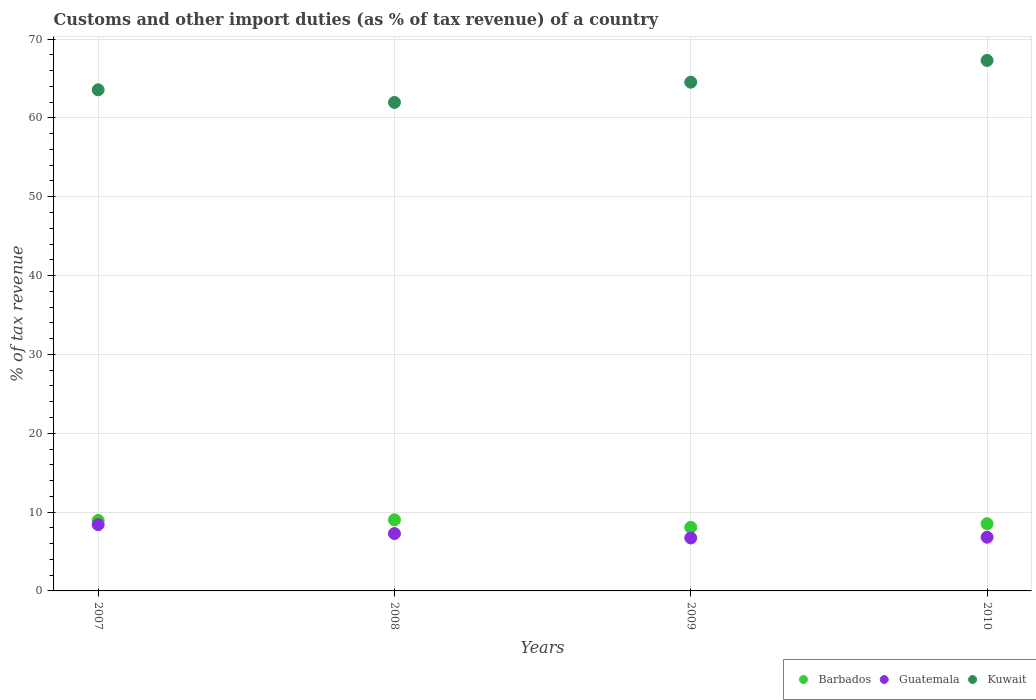Is the number of dotlines equal to the number of legend labels?
Offer a terse response. Yes. What is the percentage of tax revenue from customs in Kuwait in 2008?
Give a very brief answer. 61.96. Across all years, what is the maximum percentage of tax revenue from customs in Barbados?
Your response must be concise. 9.02. Across all years, what is the minimum percentage of tax revenue from customs in Kuwait?
Offer a terse response. 61.96. In which year was the percentage of tax revenue from customs in Guatemala maximum?
Give a very brief answer. 2007. In which year was the percentage of tax revenue from customs in Barbados minimum?
Your answer should be very brief. 2009. What is the total percentage of tax revenue from customs in Kuwait in the graph?
Keep it short and to the point. 257.33. What is the difference between the percentage of tax revenue from customs in Kuwait in 2007 and that in 2010?
Keep it short and to the point. -3.72. What is the difference between the percentage of tax revenue from customs in Kuwait in 2009 and the percentage of tax revenue from customs in Guatemala in 2008?
Your answer should be compact. 57.25. What is the average percentage of tax revenue from customs in Kuwait per year?
Provide a succinct answer. 64.33. In the year 2010, what is the difference between the percentage of tax revenue from customs in Barbados and percentage of tax revenue from customs in Kuwait?
Provide a succinct answer. -58.76. In how many years, is the percentage of tax revenue from customs in Barbados greater than 64 %?
Your response must be concise. 0. What is the ratio of the percentage of tax revenue from customs in Kuwait in 2007 to that in 2008?
Your answer should be very brief. 1.03. Is the difference between the percentage of tax revenue from customs in Barbados in 2007 and 2010 greater than the difference between the percentage of tax revenue from customs in Kuwait in 2007 and 2010?
Offer a very short reply. Yes. What is the difference between the highest and the second highest percentage of tax revenue from customs in Kuwait?
Offer a terse response. 2.76. What is the difference between the highest and the lowest percentage of tax revenue from customs in Barbados?
Your answer should be compact. 0.95. Is it the case that in every year, the sum of the percentage of tax revenue from customs in Barbados and percentage of tax revenue from customs in Kuwait  is greater than the percentage of tax revenue from customs in Guatemala?
Offer a very short reply. Yes. Does the percentage of tax revenue from customs in Guatemala monotonically increase over the years?
Offer a terse response. No. Is the percentage of tax revenue from customs in Guatemala strictly greater than the percentage of tax revenue from customs in Barbados over the years?
Keep it short and to the point. No. How many dotlines are there?
Give a very brief answer. 3. What is the difference between two consecutive major ticks on the Y-axis?
Your response must be concise. 10. Where does the legend appear in the graph?
Keep it short and to the point. Bottom right. How many legend labels are there?
Make the answer very short. 3. How are the legend labels stacked?
Keep it short and to the point. Horizontal. What is the title of the graph?
Offer a terse response. Customs and other import duties (as % of tax revenue) of a country. Does "Macedonia" appear as one of the legend labels in the graph?
Provide a short and direct response. No. What is the label or title of the Y-axis?
Your response must be concise. % of tax revenue. What is the % of tax revenue of Barbados in 2007?
Provide a succinct answer. 8.94. What is the % of tax revenue of Guatemala in 2007?
Make the answer very short. 8.41. What is the % of tax revenue in Kuwait in 2007?
Make the answer very short. 63.56. What is the % of tax revenue of Barbados in 2008?
Your answer should be very brief. 9.02. What is the % of tax revenue of Guatemala in 2008?
Your answer should be compact. 7.28. What is the % of tax revenue of Kuwait in 2008?
Your answer should be compact. 61.96. What is the % of tax revenue in Barbados in 2009?
Your answer should be very brief. 8.06. What is the % of tax revenue in Guatemala in 2009?
Provide a short and direct response. 6.72. What is the % of tax revenue in Kuwait in 2009?
Your response must be concise. 64.53. What is the % of tax revenue of Barbados in 2010?
Your answer should be compact. 8.52. What is the % of tax revenue in Guatemala in 2010?
Give a very brief answer. 6.81. What is the % of tax revenue in Kuwait in 2010?
Provide a succinct answer. 67.28. Across all years, what is the maximum % of tax revenue in Barbados?
Give a very brief answer. 9.02. Across all years, what is the maximum % of tax revenue of Guatemala?
Give a very brief answer. 8.41. Across all years, what is the maximum % of tax revenue in Kuwait?
Make the answer very short. 67.28. Across all years, what is the minimum % of tax revenue of Barbados?
Provide a succinct answer. 8.06. Across all years, what is the minimum % of tax revenue of Guatemala?
Your answer should be compact. 6.72. Across all years, what is the minimum % of tax revenue of Kuwait?
Your answer should be compact. 61.96. What is the total % of tax revenue of Barbados in the graph?
Offer a very short reply. 34.54. What is the total % of tax revenue of Guatemala in the graph?
Your answer should be compact. 29.22. What is the total % of tax revenue of Kuwait in the graph?
Keep it short and to the point. 257.33. What is the difference between the % of tax revenue of Barbados in 2007 and that in 2008?
Make the answer very short. -0.08. What is the difference between the % of tax revenue of Guatemala in 2007 and that in 2008?
Offer a terse response. 1.13. What is the difference between the % of tax revenue of Kuwait in 2007 and that in 2008?
Your answer should be very brief. 1.6. What is the difference between the % of tax revenue in Barbados in 2007 and that in 2009?
Make the answer very short. 0.88. What is the difference between the % of tax revenue in Guatemala in 2007 and that in 2009?
Offer a very short reply. 1.69. What is the difference between the % of tax revenue of Kuwait in 2007 and that in 2009?
Offer a terse response. -0.97. What is the difference between the % of tax revenue of Barbados in 2007 and that in 2010?
Your answer should be compact. 0.42. What is the difference between the % of tax revenue in Guatemala in 2007 and that in 2010?
Give a very brief answer. 1.6. What is the difference between the % of tax revenue in Kuwait in 2007 and that in 2010?
Provide a succinct answer. -3.72. What is the difference between the % of tax revenue of Barbados in 2008 and that in 2009?
Your answer should be very brief. 0.95. What is the difference between the % of tax revenue in Guatemala in 2008 and that in 2009?
Give a very brief answer. 0.56. What is the difference between the % of tax revenue in Kuwait in 2008 and that in 2009?
Offer a very short reply. -2.57. What is the difference between the % of tax revenue of Barbados in 2008 and that in 2010?
Provide a succinct answer. 0.5. What is the difference between the % of tax revenue of Guatemala in 2008 and that in 2010?
Keep it short and to the point. 0.46. What is the difference between the % of tax revenue of Kuwait in 2008 and that in 2010?
Provide a short and direct response. -5.32. What is the difference between the % of tax revenue in Barbados in 2009 and that in 2010?
Your response must be concise. -0.46. What is the difference between the % of tax revenue of Guatemala in 2009 and that in 2010?
Give a very brief answer. -0.09. What is the difference between the % of tax revenue in Kuwait in 2009 and that in 2010?
Give a very brief answer. -2.76. What is the difference between the % of tax revenue in Barbados in 2007 and the % of tax revenue in Guatemala in 2008?
Make the answer very short. 1.66. What is the difference between the % of tax revenue in Barbados in 2007 and the % of tax revenue in Kuwait in 2008?
Offer a very short reply. -53.02. What is the difference between the % of tax revenue of Guatemala in 2007 and the % of tax revenue of Kuwait in 2008?
Keep it short and to the point. -53.55. What is the difference between the % of tax revenue of Barbados in 2007 and the % of tax revenue of Guatemala in 2009?
Provide a short and direct response. 2.22. What is the difference between the % of tax revenue of Barbados in 2007 and the % of tax revenue of Kuwait in 2009?
Keep it short and to the point. -55.59. What is the difference between the % of tax revenue of Guatemala in 2007 and the % of tax revenue of Kuwait in 2009?
Your response must be concise. -56.12. What is the difference between the % of tax revenue of Barbados in 2007 and the % of tax revenue of Guatemala in 2010?
Offer a terse response. 2.13. What is the difference between the % of tax revenue of Barbados in 2007 and the % of tax revenue of Kuwait in 2010?
Keep it short and to the point. -58.34. What is the difference between the % of tax revenue in Guatemala in 2007 and the % of tax revenue in Kuwait in 2010?
Your answer should be compact. -58.88. What is the difference between the % of tax revenue in Barbados in 2008 and the % of tax revenue in Guatemala in 2009?
Provide a short and direct response. 2.3. What is the difference between the % of tax revenue in Barbados in 2008 and the % of tax revenue in Kuwait in 2009?
Ensure brevity in your answer.  -55.51. What is the difference between the % of tax revenue of Guatemala in 2008 and the % of tax revenue of Kuwait in 2009?
Provide a succinct answer. -57.25. What is the difference between the % of tax revenue in Barbados in 2008 and the % of tax revenue in Guatemala in 2010?
Give a very brief answer. 2.21. What is the difference between the % of tax revenue of Barbados in 2008 and the % of tax revenue of Kuwait in 2010?
Keep it short and to the point. -58.27. What is the difference between the % of tax revenue of Guatemala in 2008 and the % of tax revenue of Kuwait in 2010?
Ensure brevity in your answer.  -60.01. What is the difference between the % of tax revenue in Barbados in 2009 and the % of tax revenue in Guatemala in 2010?
Make the answer very short. 1.25. What is the difference between the % of tax revenue of Barbados in 2009 and the % of tax revenue of Kuwait in 2010?
Your response must be concise. -59.22. What is the difference between the % of tax revenue of Guatemala in 2009 and the % of tax revenue of Kuwait in 2010?
Give a very brief answer. -60.56. What is the average % of tax revenue in Barbados per year?
Your response must be concise. 8.64. What is the average % of tax revenue of Guatemala per year?
Your answer should be compact. 7.3. What is the average % of tax revenue in Kuwait per year?
Make the answer very short. 64.33. In the year 2007, what is the difference between the % of tax revenue of Barbados and % of tax revenue of Guatemala?
Your answer should be compact. 0.53. In the year 2007, what is the difference between the % of tax revenue of Barbados and % of tax revenue of Kuwait?
Offer a very short reply. -54.62. In the year 2007, what is the difference between the % of tax revenue of Guatemala and % of tax revenue of Kuwait?
Your answer should be very brief. -55.15. In the year 2008, what is the difference between the % of tax revenue of Barbados and % of tax revenue of Guatemala?
Make the answer very short. 1.74. In the year 2008, what is the difference between the % of tax revenue in Barbados and % of tax revenue in Kuwait?
Give a very brief answer. -52.94. In the year 2008, what is the difference between the % of tax revenue in Guatemala and % of tax revenue in Kuwait?
Make the answer very short. -54.68. In the year 2009, what is the difference between the % of tax revenue of Barbados and % of tax revenue of Guatemala?
Your response must be concise. 1.34. In the year 2009, what is the difference between the % of tax revenue in Barbados and % of tax revenue in Kuwait?
Provide a short and direct response. -56.46. In the year 2009, what is the difference between the % of tax revenue of Guatemala and % of tax revenue of Kuwait?
Your answer should be very brief. -57.81. In the year 2010, what is the difference between the % of tax revenue of Barbados and % of tax revenue of Guatemala?
Your response must be concise. 1.71. In the year 2010, what is the difference between the % of tax revenue of Barbados and % of tax revenue of Kuwait?
Offer a terse response. -58.76. In the year 2010, what is the difference between the % of tax revenue in Guatemala and % of tax revenue in Kuwait?
Ensure brevity in your answer.  -60.47. What is the ratio of the % of tax revenue of Barbados in 2007 to that in 2008?
Your answer should be compact. 0.99. What is the ratio of the % of tax revenue in Guatemala in 2007 to that in 2008?
Give a very brief answer. 1.16. What is the ratio of the % of tax revenue in Kuwait in 2007 to that in 2008?
Provide a short and direct response. 1.03. What is the ratio of the % of tax revenue of Barbados in 2007 to that in 2009?
Offer a very short reply. 1.11. What is the ratio of the % of tax revenue in Guatemala in 2007 to that in 2009?
Make the answer very short. 1.25. What is the ratio of the % of tax revenue of Barbados in 2007 to that in 2010?
Your answer should be very brief. 1.05. What is the ratio of the % of tax revenue in Guatemala in 2007 to that in 2010?
Offer a terse response. 1.23. What is the ratio of the % of tax revenue of Kuwait in 2007 to that in 2010?
Offer a very short reply. 0.94. What is the ratio of the % of tax revenue in Barbados in 2008 to that in 2009?
Provide a short and direct response. 1.12. What is the ratio of the % of tax revenue of Guatemala in 2008 to that in 2009?
Provide a succinct answer. 1.08. What is the ratio of the % of tax revenue in Kuwait in 2008 to that in 2009?
Your answer should be very brief. 0.96. What is the ratio of the % of tax revenue in Barbados in 2008 to that in 2010?
Your response must be concise. 1.06. What is the ratio of the % of tax revenue in Guatemala in 2008 to that in 2010?
Your answer should be very brief. 1.07. What is the ratio of the % of tax revenue of Kuwait in 2008 to that in 2010?
Offer a very short reply. 0.92. What is the ratio of the % of tax revenue of Barbados in 2009 to that in 2010?
Offer a terse response. 0.95. What is the ratio of the % of tax revenue in Guatemala in 2009 to that in 2010?
Make the answer very short. 0.99. What is the ratio of the % of tax revenue of Kuwait in 2009 to that in 2010?
Provide a succinct answer. 0.96. What is the difference between the highest and the second highest % of tax revenue of Barbados?
Your response must be concise. 0.08. What is the difference between the highest and the second highest % of tax revenue of Guatemala?
Offer a terse response. 1.13. What is the difference between the highest and the second highest % of tax revenue in Kuwait?
Your response must be concise. 2.76. What is the difference between the highest and the lowest % of tax revenue in Barbados?
Keep it short and to the point. 0.95. What is the difference between the highest and the lowest % of tax revenue in Guatemala?
Provide a succinct answer. 1.69. What is the difference between the highest and the lowest % of tax revenue in Kuwait?
Offer a terse response. 5.32. 